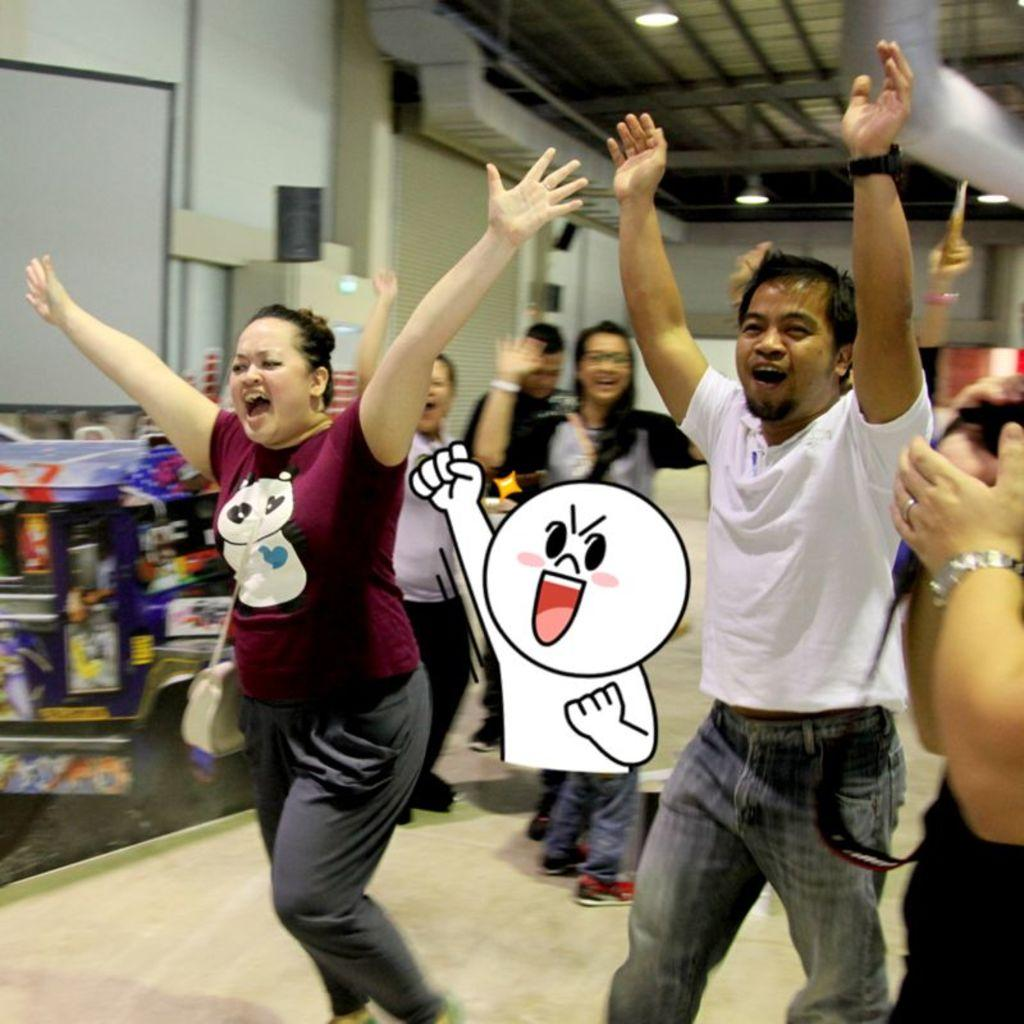What types of people are in the hall? There are men and women in the hall. What are the people in the hall doing with their hands? The people in the hall are raising their hands up. What can be seen on the walls in the background? There are white walls in the background. What is present on the ceiling in the hall? Ducts and spotlights are visible on the ceiling. What type of spy equipment can be seen on the unit in the image? There is no spy equipment or unit present in the image. What color are the teeth of the people in the image? The image does not show the teeth of the people, so it cannot be determined from the image. 